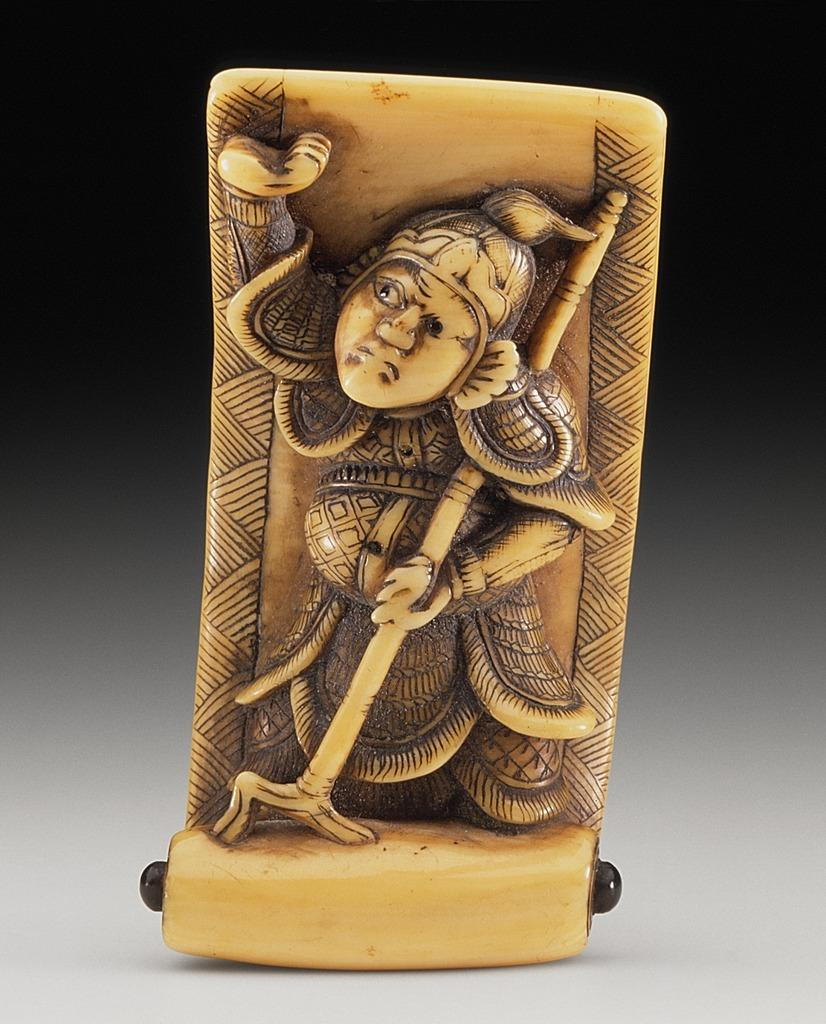What is the main subject of the image? There is a sculpture of a person in the image. Can you describe the sculpture in more detail? Unfortunately, the provided facts do not offer any additional details about the sculpture. What might the sculpture be made of? The material used to create the sculpture is not mentioned in the given facts. How does the cart contribute to the pollution in the image? There is no cart present in the image, and therefore no pollution can be attributed to it. 